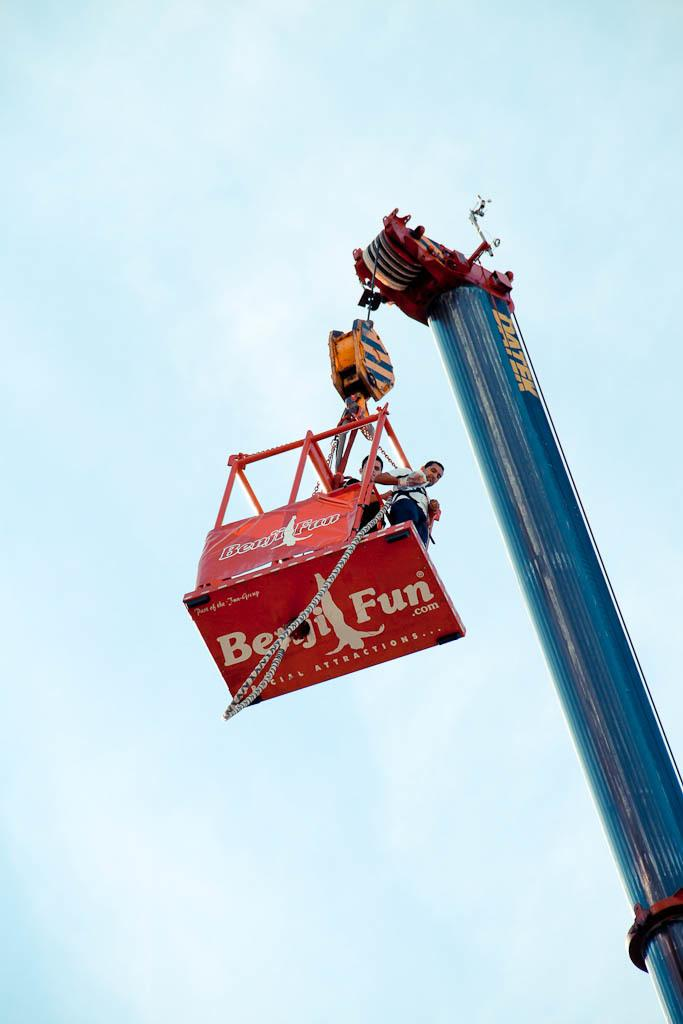What is the main subject in the center of the image? There is a crane in the center of the image. What are the two persons doing in the image? Two persons are standing in the crane bucket. What can be seen in the background of the image? The sky is visible in the background of the image. What type of weather is suggested by the background? Clouds are present in the background of the image, suggesting a partly cloudy day. What type of school can be seen in the image? There is no school present in the image; it features a crane with two persons in the bucket. How does the parent interact with the pump in the image? There is no pump or parent present in the image. 